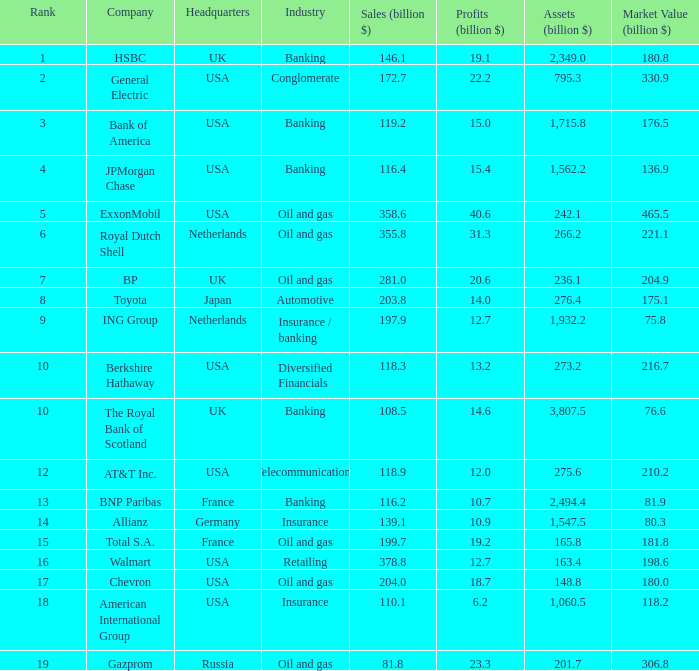What is the total profit in billions for businesses with a market valuation of 20 20.6. 